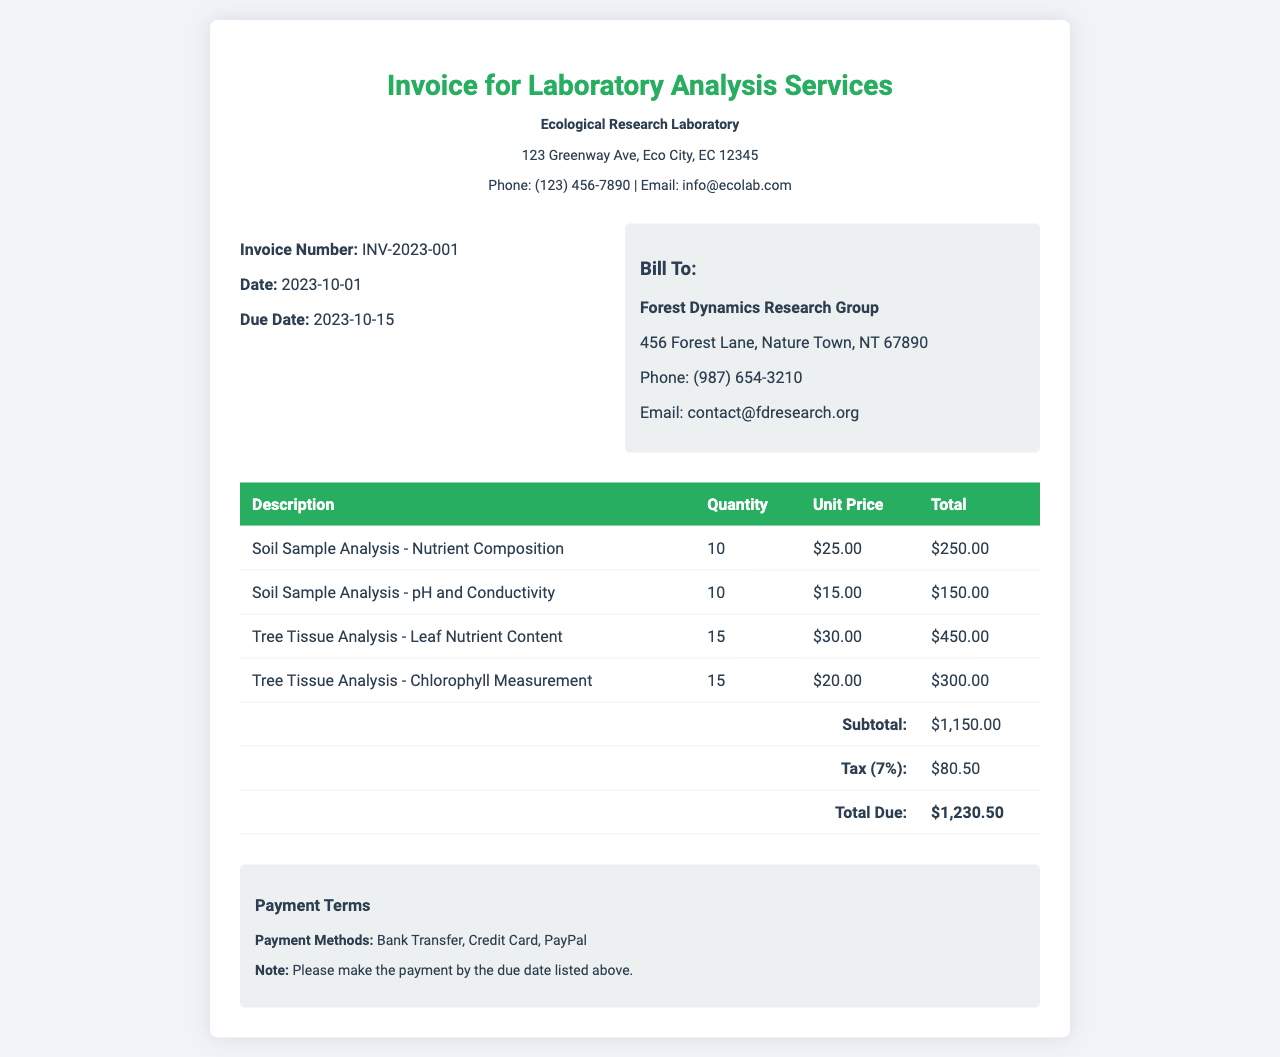what is the invoice number? The invoice number listed in the document is used to uniquely identify this particular invoice, which is INV-2023-001.
Answer: INV-2023-001 who is the client? The client is the entity being billed for the laboratory analysis services, which is the Forest Dynamics Research Group.
Answer: Forest Dynamics Research Group what is the due date? The due date indicates by when the payment should be made, which is 2023-10-15.
Answer: 2023-10-15 how many soil sample analyses for pH and conductivity were conducted? The quantity indicates how many analyses were performed, which is 10.
Answer: 10 what is the subtotal amount before tax? The subtotal is the total cost of the services rendered before tax is added, which totals $1,150.00.
Answer: $1,150.00 what is the total amount due including tax? The total due is the complete amount owed by the client after including tax, which sums up to $1,230.50.
Answer: $1,230.50 what is the tax rate applied? The tax rate gives the percentage of the subtotal charged as tax, which is 7%.
Answer: 7% how many tree tissue analyses were performed? The total number of tree tissue analyses includes both types: leaf nutrient content and chlorophyll measurement, totaling 30.
Answer: 30 what payment methods are mentioned? The document lists the various payment methods available for settling the invoice, which are Bank Transfer, Credit Card, and PayPal.
Answer: Bank Transfer, Credit Card, PayPal 